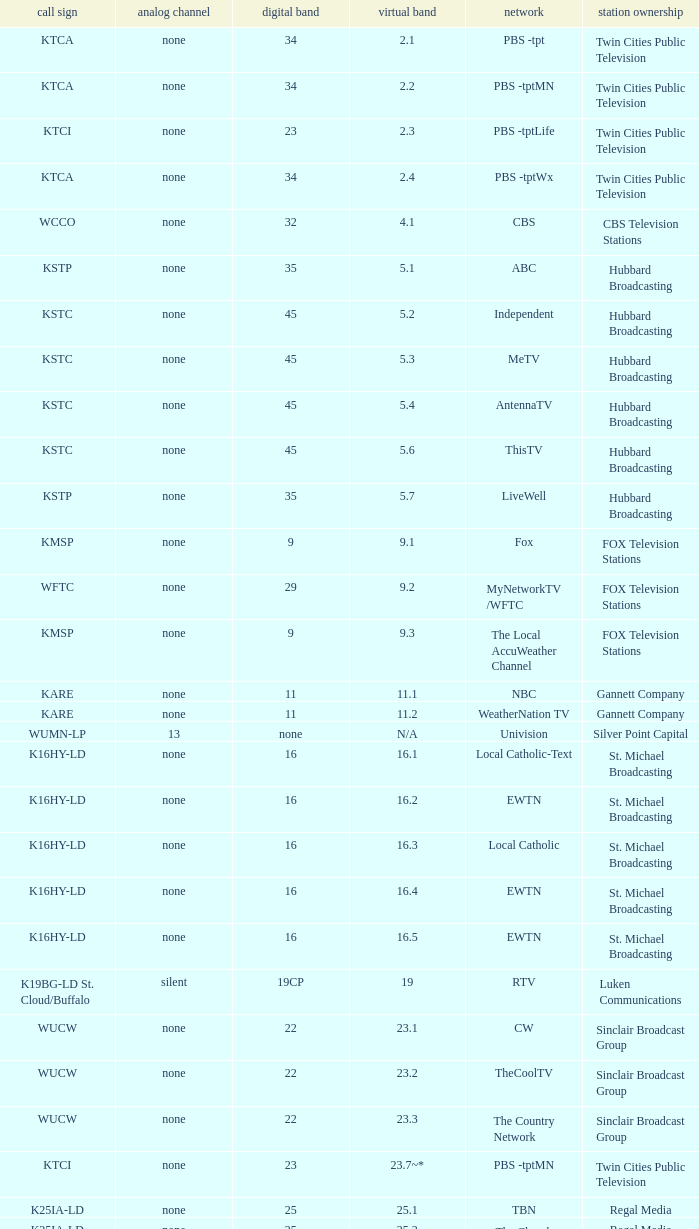Network of nbc is what digital channel? 11.0. 